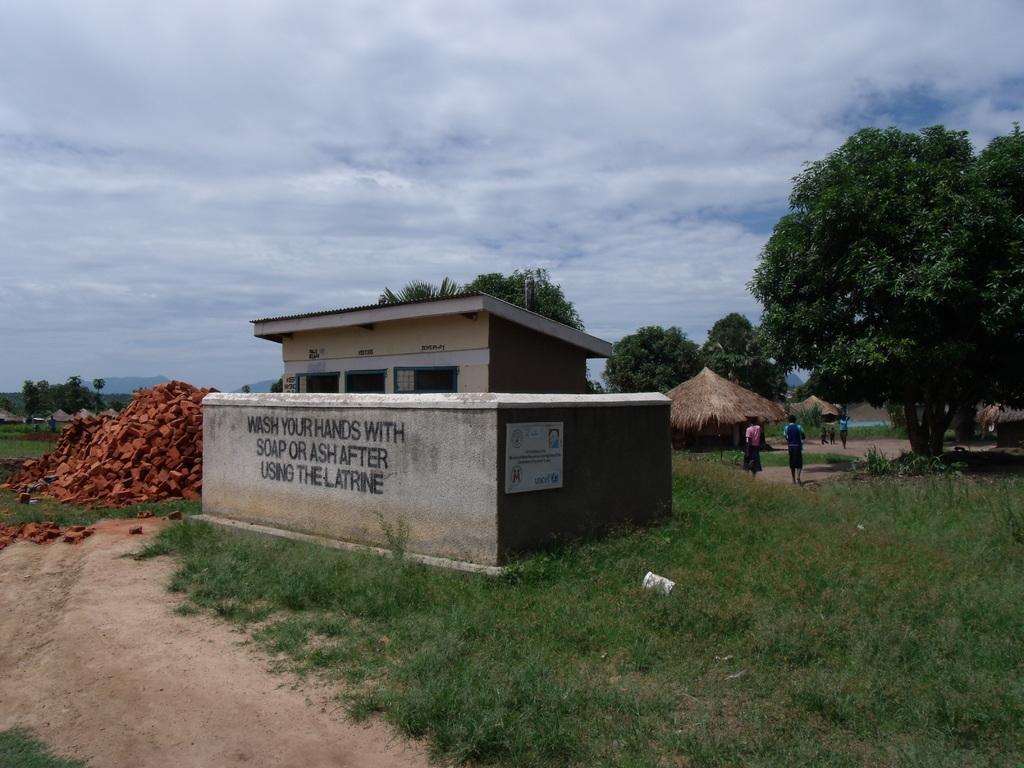In one or two sentences, can you explain what this image depicts? In the middle of this image, there is a building having windows and a roof and there is a wall around this building. On the left side, there are bricks on the ground, on which there is grass, and there is a road. On the right side, there are trees, shelters and children. In the background, there are trees, mountains and there are clouds in the sky. 